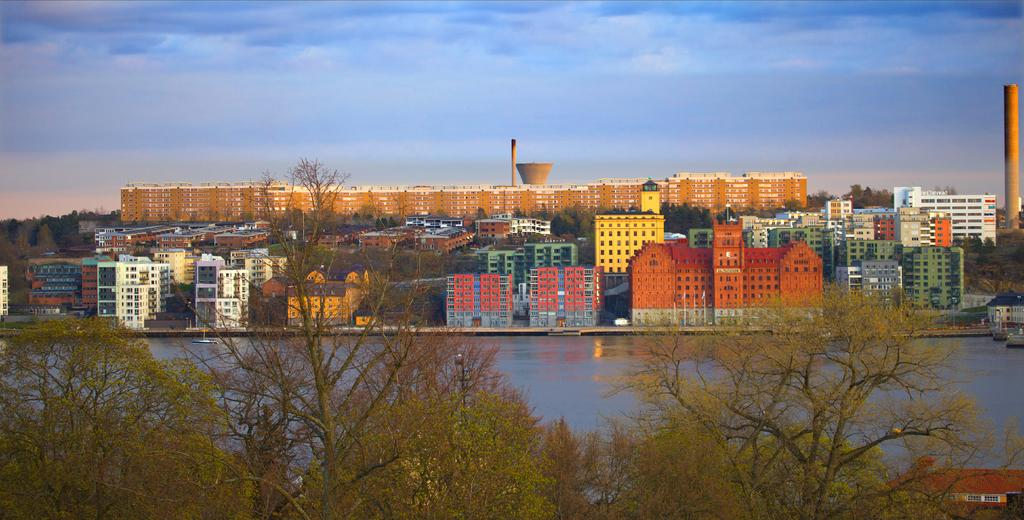What is located in the foreground of the image? There are trees in the foreground of the image. What structures can be seen in the middle of the image? There are buildings in the middle of the image. What is visible in the background of the image? The background of the image is the sky. Where is the hall located in the image? There is no hall present in the image. Can you see any beans in the image? There are no beans present in the image. 